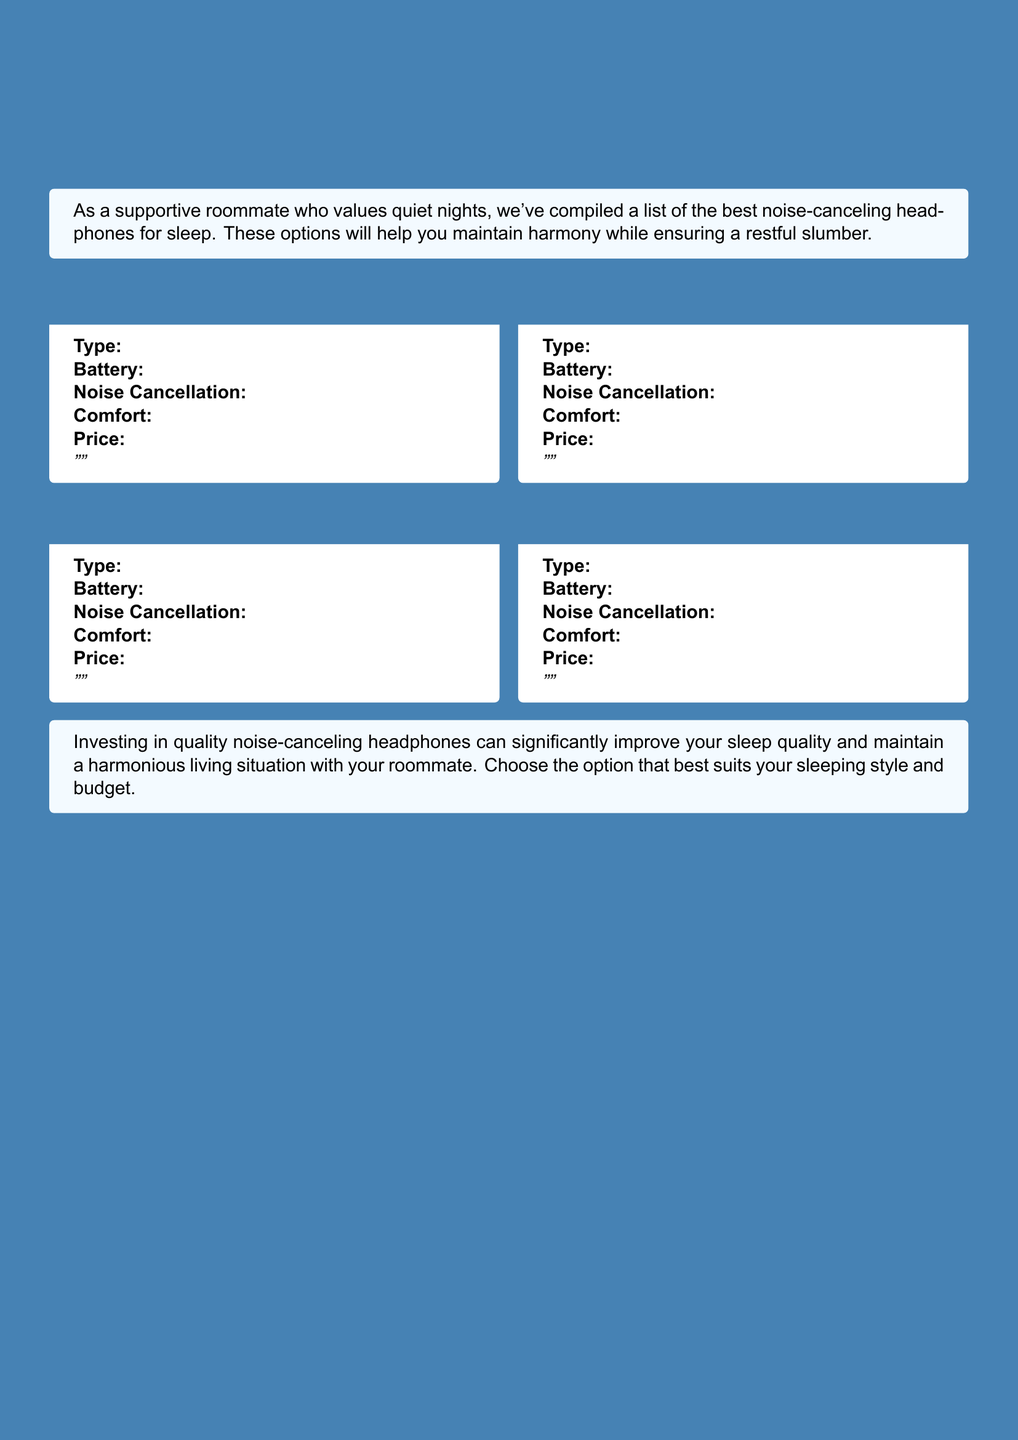What is the title of the document? The title of the document is prominently displayed at the top, indicating its focus on headphones for sleep.
Answer: Top Noise-Canceling Headphones for Peaceful Sleep How many headphone models are listed in the document? The document lists a total of four headphone models, each contained in a separate box.
Answer: 4 What is the main color used in the document? The main color is used for headings and highlights throughout the document.
Answer: Steel Blue What is the intended purpose of these headphones according to the document? The document states their purpose to help in achieving restful sleep and maintaining harmony with roommates.
Answer: Peaceful sleep Which aspect of the headphones is highlighted along with comfort and price? The document notes the importance of noise cancellation in the context of selecting headphones for sleep.
Answer: Noise Cancellation What type of document is this? The document is structured to showcase different products with specifications and reviews, typical for a product catalog.
Answer: Catalog What are two features mentioned for selecting headphones in the document? Features like battery life and comfort are mentioned as important for selecting headphones.
Answer: Battery life, comfort Which color accompanies the supportive message about headphones for sleep? The supporting message about the headphones uses a light shade of blue.
Answer: Light Blue 